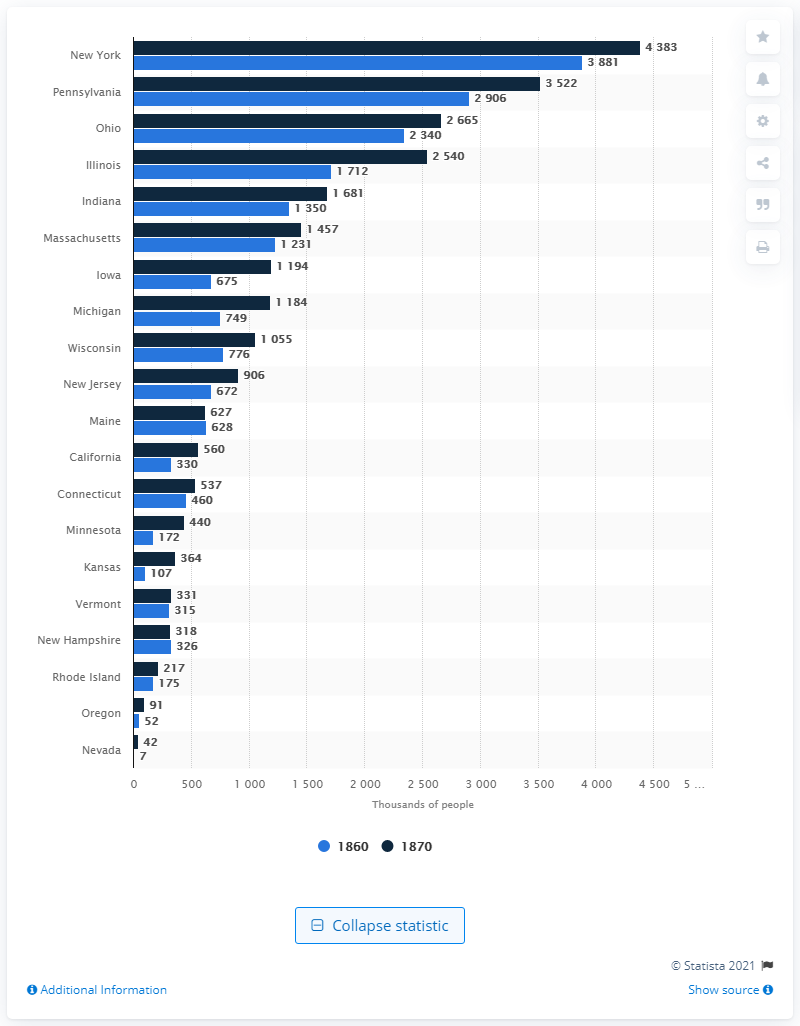Point out several critical features in this image. Illinois had the largest population growth among all the states. 